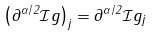Convert formula to latex. <formula><loc_0><loc_0><loc_500><loc_500>\left ( \partial ^ { \alpha / 2 } \mathcal { I } g \right ) _ { j } = \partial ^ { \alpha / 2 } \mathcal { I } g _ { j }</formula> 